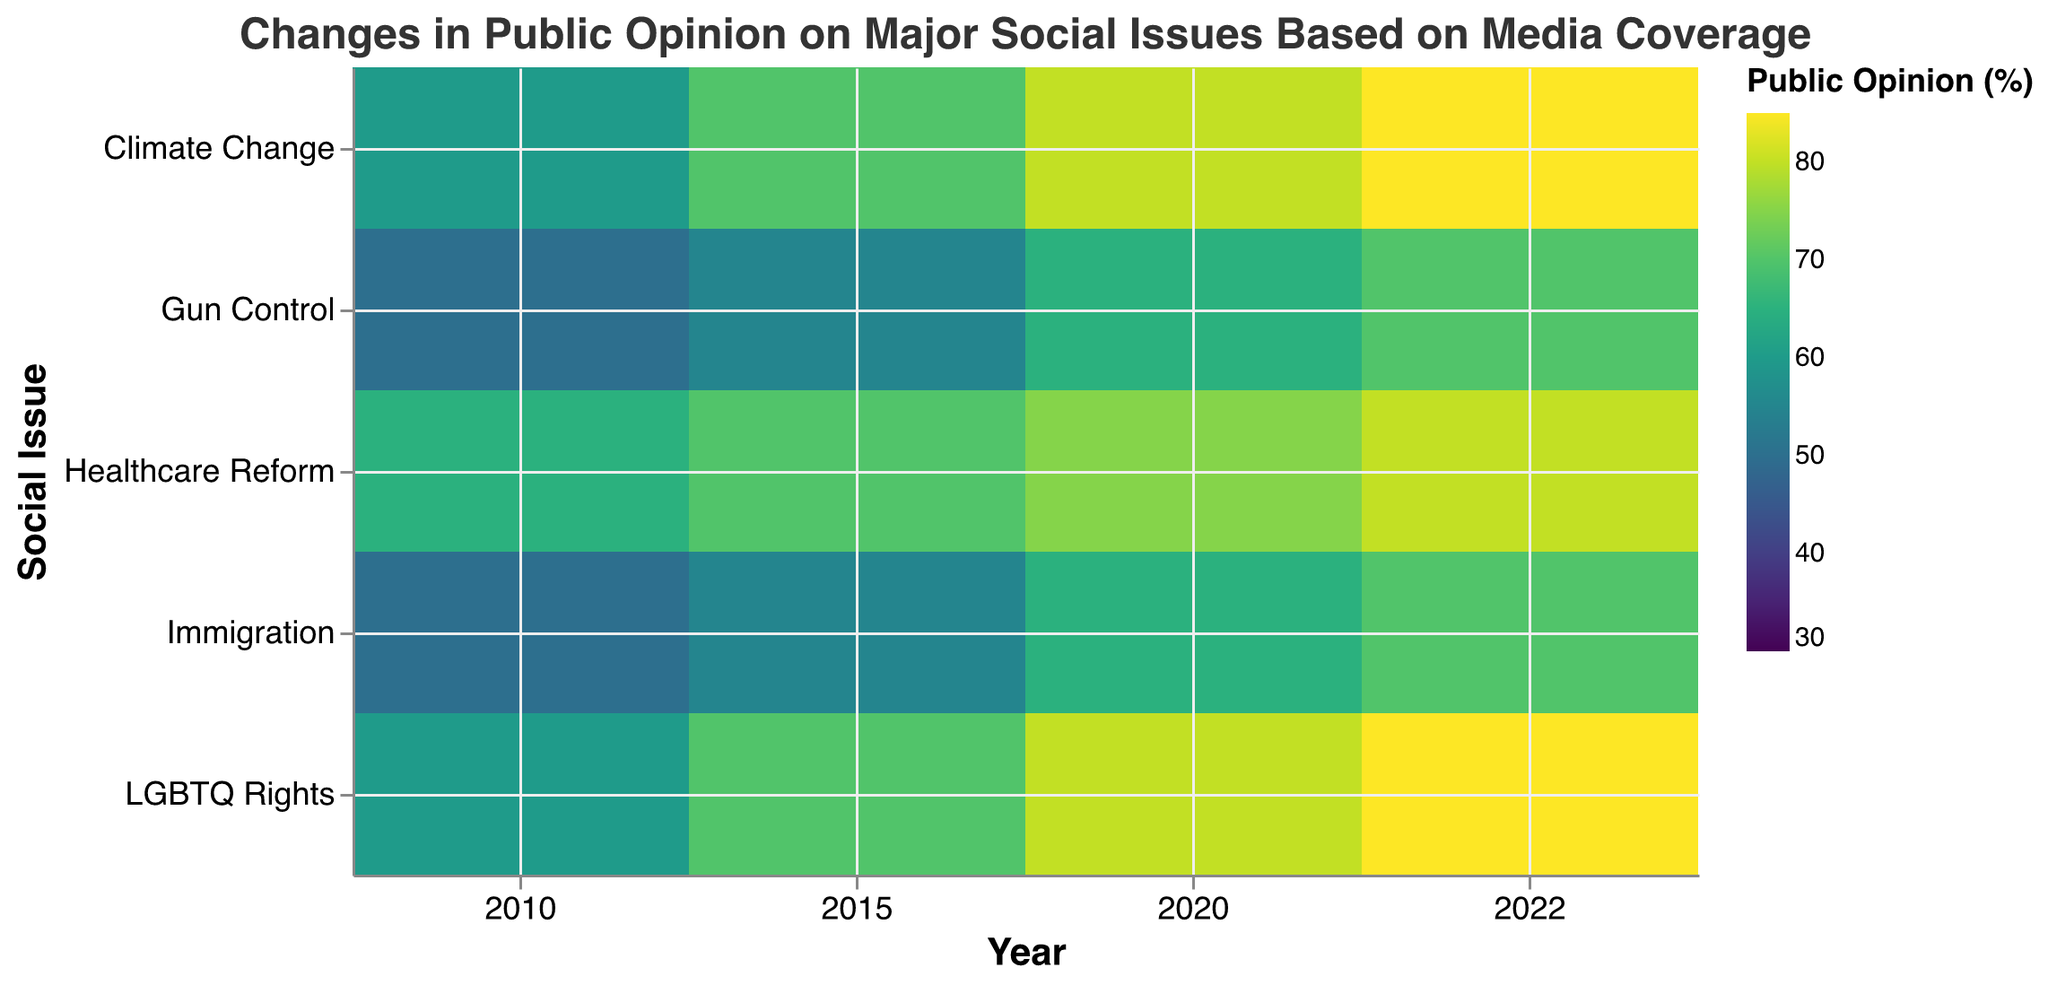What is the title of the heatmap? The title is displayed at the top of the heatmap. It reads "Changes in Public Opinion on Major Social Issues Based on Media Coverage".
Answer: Changes in Public Opinion on Major Social Issues Based on Media Coverage Which media outlet shows the highest public opinion score for Climate Change in 2010? By examining the heatmap, find the values corresponding to Climate Change in 2010. The highest value among the given media outlets (45, 50, 60, 30, 55) is shown by CNN.
Answer: CNN What is the difference in public opinion on Gun Control between CNN and Fox News in 2020? Identify the public opinion values for Gun Control in 2020 for CNN and Fox News, which are 65 and 70 respectively. The difference is 70 - 65.
Answer: 5 Which social issue had the highest increase in public opinion from 2010 to 2022 according to Fox News? Track the values for each social issue over the years for Fox News. Calculate the difference in values from 2010 to 2022. The largest increase can be observed for Gun Control (75 - 60 = 15).
Answer: Gun Control How does the public opinion on Healthcare Reform in 2020 compare between the New York Times and BBC? Compare the values of Healthcare Reform in 2020 for the New York Times (70) and BBC (60). The New York Times has a higher public opinion score by 10 points.
Answer: New York Times has a higher score by 10 points What trend can be observed in the public opinion on LGBTQ Rights across all media outlets from 2010 to 2022? Observing the heatmap, you'll notice that the public opinion on LGBTQ Rights increases consistently over the years across all media outlets. For example, in New York Times: 50 (2010) to 75 (2022).
Answer: Increasing trend across all media outlets Which social issue and year show the lowest public opinion score according to Fox News? Search for the lowest values on the heatmap under Fox News's column, across all issues and years. The lowest value is 30 for Climate Change in 2010.
Answer: Climate Change, 2010 What’s the average public opinion on Immigration in 2022 across all the media outlets? Add the public opinion scores for Immigration in 2022 across all media outlets and divide by the number of media outlets. (55 + 60 + 70 + 70 + 60) / 5 = 63.
Answer: 63 